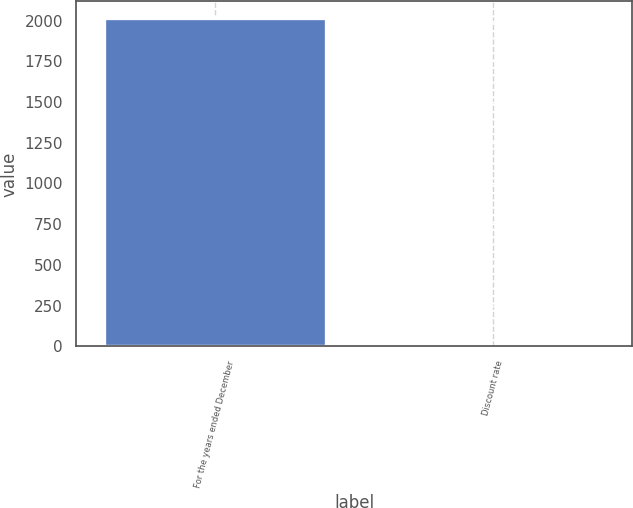Convert chart. <chart><loc_0><loc_0><loc_500><loc_500><bar_chart><fcel>For the years ended December<fcel>Discount rate<nl><fcel>2017<fcel>3.8<nl></chart> 